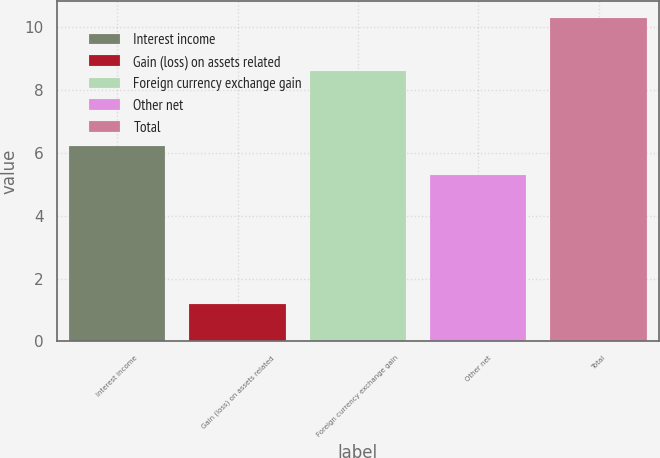<chart> <loc_0><loc_0><loc_500><loc_500><bar_chart><fcel>Interest income<fcel>Gain (loss) on assets related<fcel>Foreign currency exchange gain<fcel>Other net<fcel>Total<nl><fcel>6.21<fcel>1.2<fcel>8.6<fcel>5.3<fcel>10.3<nl></chart> 